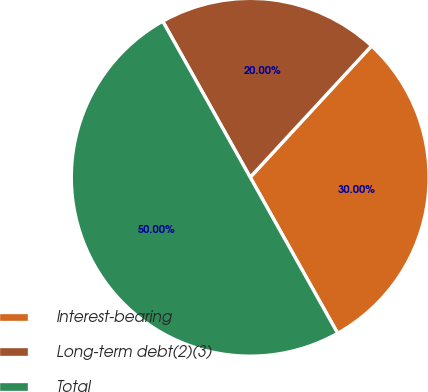Convert chart. <chart><loc_0><loc_0><loc_500><loc_500><pie_chart><fcel>Interest-bearing<fcel>Long-term debt(2)(3)<fcel>Total<nl><fcel>30.0%<fcel>20.0%<fcel>50.0%<nl></chart> 